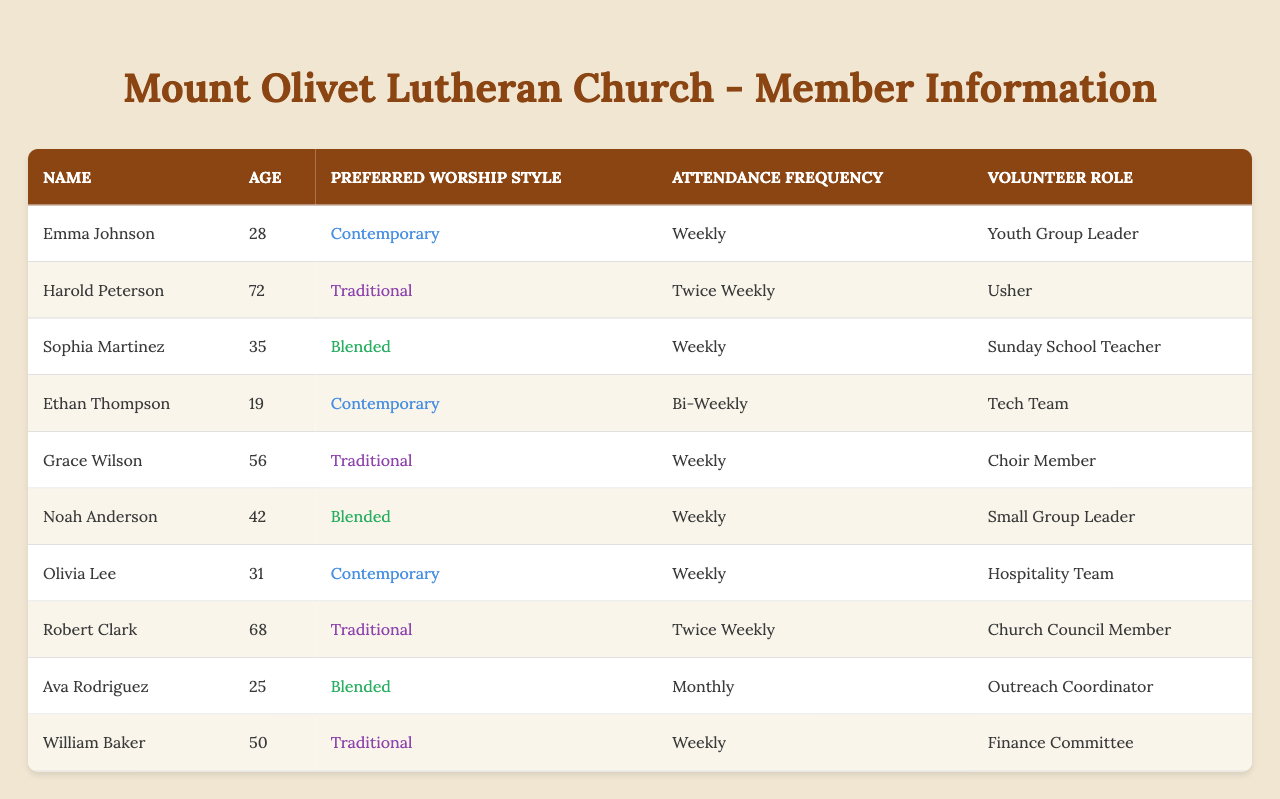What is the average age of the church members? To find the average age, I need to sum all the ages: 28 + 72 + 35 + 19 + 56 + 42 + 31 + 68 + 25 + 50 =  426. There are 10 members, so the average age is 426 divided by 10, which equals 42.6.
Answer: 42.6 How many members have a preference for Traditional worship style? To find this out, I count the number of times "Traditional" appears in the preferred worship style column. It appears for Harold Peterson, Grace Wilson, Robert Clark, and William Baker, totaling 4 members.
Answer: 4 Is there any member who volunteers as a Sunday School Teacher? I will scan the volunteer role column to see if "Sunday School Teacher" is listed. It is indeed listed next to Sophia Martinez, so the answer is yes.
Answer: Yes What is the attendance frequency of the youngest member? I will first identify the youngest member, who is Ethan Thompson at age 19. Then I will check the attendance frequency listed for him, which is "Bi-Weekly."
Answer: Bi-Weekly Which worship style is preferred by the oldest member? The oldest member is Harold Peterson, who is 72 years old. I will check the preferred worship style listed for him, which is "Traditional."
Answer: Traditional How many members prefer Contemporary worship style, and how does that compare to those who prefer Blended worship style? I count the members for each style. Contemporary has Emma Johnson, Ethan Thompson, and Olivia Lee, totaling 3 members. Blended has Sophia Martinez, Noah Anderson, and Ava Rodriguez, totaling 3 members. Both styles are equally preferred with 3 members each.
Answer: Both have 3 members What is the total number of members who attend church weekly? I look through the attendance frequency column and count. The members attending weekly are Emma Johnson, Sophia Martinez, Grace Wilson, Noah Anderson, Olivia Lee, and William Baker, making a total of 6.
Answer: 6 Which member has a volunteer role related to kids? I will check the volunteer roles for members. The only member listed with a role directly related to kids is Sophia Martinez, who is a Sunday School Teacher.
Answer: Sophia Martinez What is the median age of the church members? First, I list the ages in order: 19, 25, 28, 31, 35, 42, 50, 56, 68, 72. Since there are 10 members, the median will be the average of the 5th and 6th ages: (35 + 42) / 2 = 38.5.
Answer: 38.5 Does any member have a volunteer role that includes the word "Leader"? I will scan through the volunteer role column. Yes, Emma Johnson is a Youth Group Leader, and Noah Anderson is a Small Group Leader. Therefore, the answer is yes.
Answer: Yes What percentage of the members prefer a worship style that is Traditional? There are 10 total members, and 4 prefer Traditional. To find the percentage, I calculate (4/10) * 100 = 40%.
Answer: 40% 